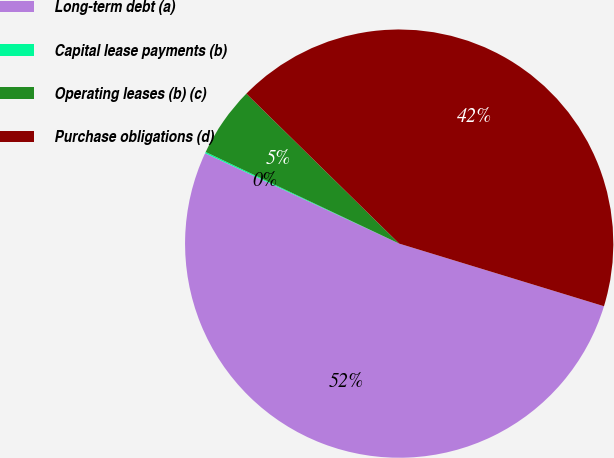Convert chart. <chart><loc_0><loc_0><loc_500><loc_500><pie_chart><fcel>Long-term debt (a)<fcel>Capital lease payments (b)<fcel>Operating leases (b) (c)<fcel>Purchase obligations (d)<nl><fcel>52.21%<fcel>0.1%<fcel>5.31%<fcel>42.37%<nl></chart> 